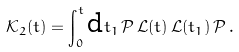Convert formula to latex. <formula><loc_0><loc_0><loc_500><loc_500>\mathcal { K } _ { 2 } ( t ) = \int _ { 0 } ^ { t } \text {d} t _ { 1 } \, \mathcal { P } \, \mathcal { L } ( t ) \, \mathcal { L } ( t _ { 1 } ) \, \mathcal { P } \, .</formula> 